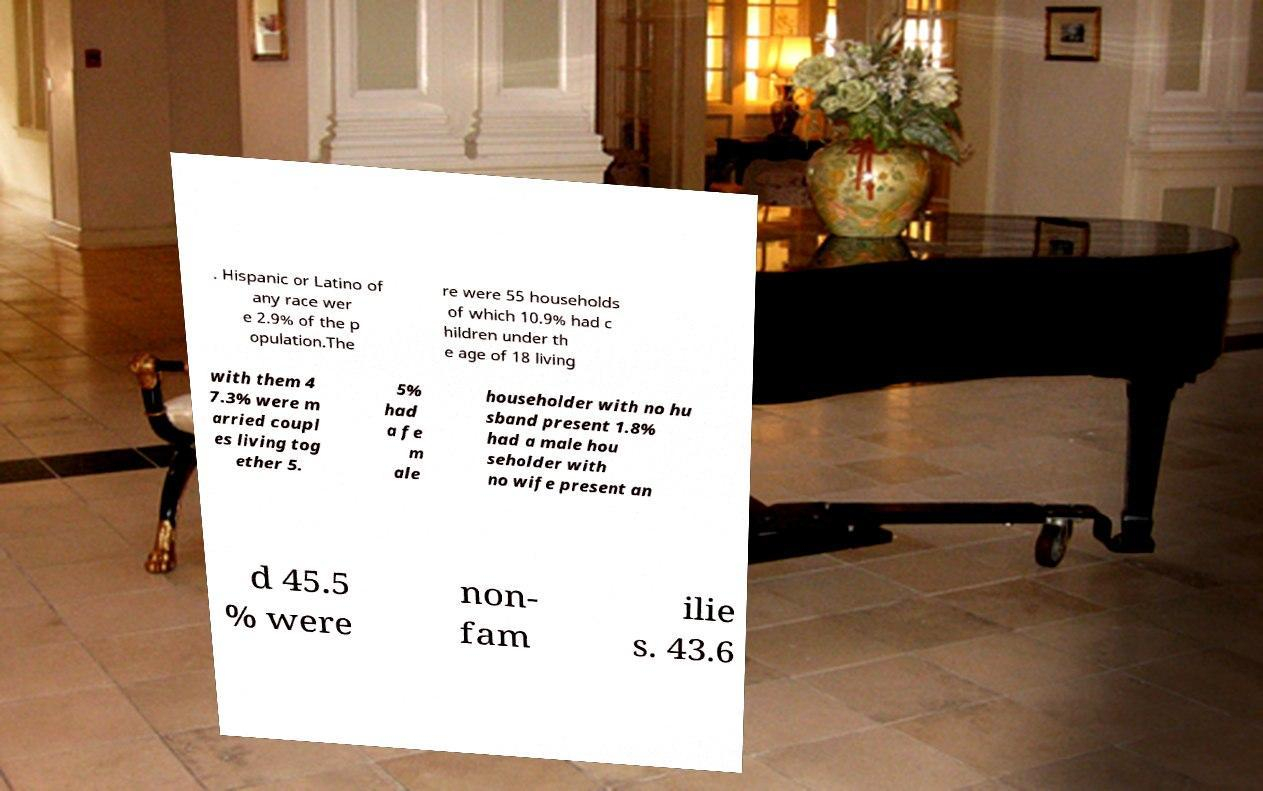Please identify and transcribe the text found in this image. . Hispanic or Latino of any race wer e 2.9% of the p opulation.The re were 55 households of which 10.9% had c hildren under th e age of 18 living with them 4 7.3% were m arried coupl es living tog ether 5. 5% had a fe m ale householder with no hu sband present 1.8% had a male hou seholder with no wife present an d 45.5 % were non- fam ilie s. 43.6 